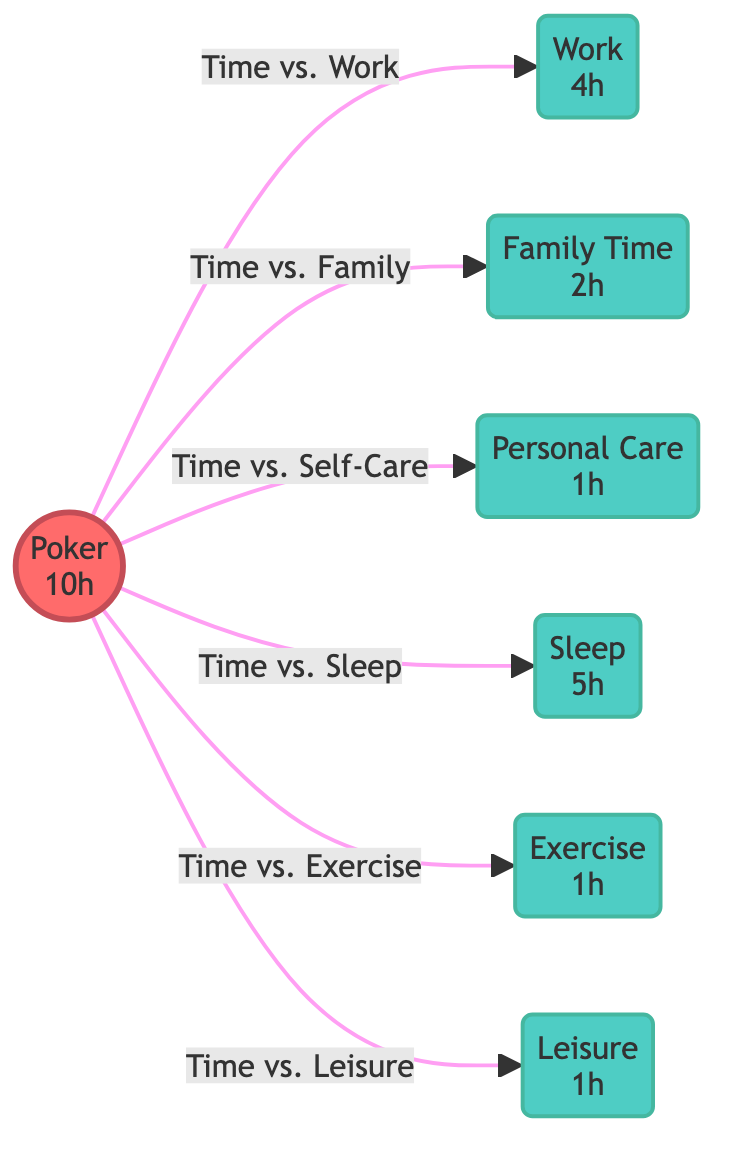What is the total number of hours allocated to poker in the diagram? The diagram explicitly states the number of hours next to the poker node, which is 10 hours.
Answer: 10h How many hours are spent on family time according to the diagram? The family time node indicates directly that there are 2 hours spent on family time.
Answer: 2h What is the average number of hours spent per activity excluding poker? To find the average, sum the hours of work (4h), family time (2h), personal care (1h), sleep (5h), exercise (1h), and leisure (1h), which totals 14 hours. Then, divide by the number of activities (6), resulting in an average of approximately 2.33.
Answer: 2.33h What are the activities that require less time than poker? By comparing the hours allocated to poker (10h) with each activity, work (4h), family time (2h), personal care (1h), sleep (5h), exercise (1h), and leisure (1h) are all less than 10 hours.
Answer: Work, Family Time, Personal Care, Sleep, Exercise, Leisure Which activity has the least time allocated? The diagram shows the hours next to each activity, and personal care, exercise, and leisure are each 1 hour, making them the least allocated activities.
Answer: Personal Care, Exercise, Leisure How does poker time compare to sleep time? The diagram shows that poker time is 10 hours and sleep time is 5 hours. When comparing, 10 hours of poker is twice that of sleep time.
Answer: 2 times What is the relationship between poker and leisure time? The diagram indicates that poker is connected to leisure, and directly shows that poker (10h) has more time than leisure (1h), establishing a one-way relationship where poker takes up considerably more time.
Answer: More Time How many edges are there originating from the poker node? The diagram presents several edges leading away from the poker node towards work, family time, personal care, sleep, exercise, and leisure, totaling 6 edges.
Answer: 6 Which activity is allocated more time than personal care? Comparing the time allocations, work (4h), family time (2h), sleep (5h), and poker (10h) all exceed the personal care time of 1 hour.
Answer: Work, Family Time, Sleep, Poker 